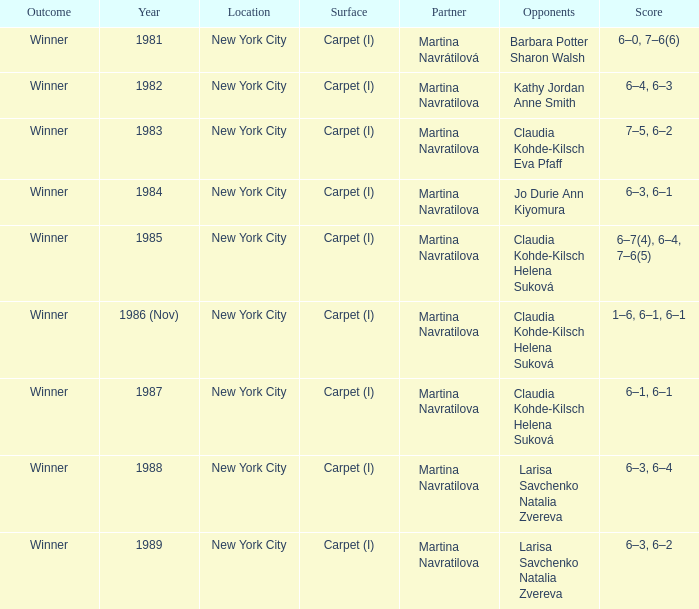How many venues hosted claudia kohde-kilsch eva pfaff? 1.0. 